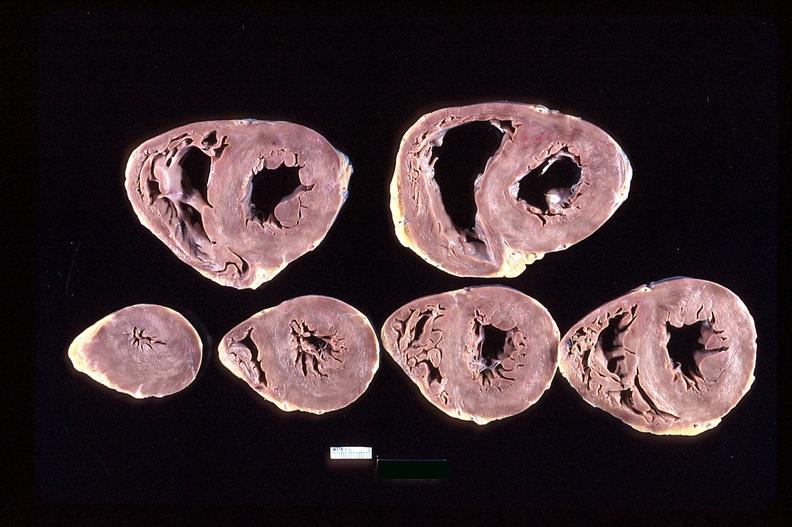what is present?
Answer the question using a single word or phrase. Cardiovascular 